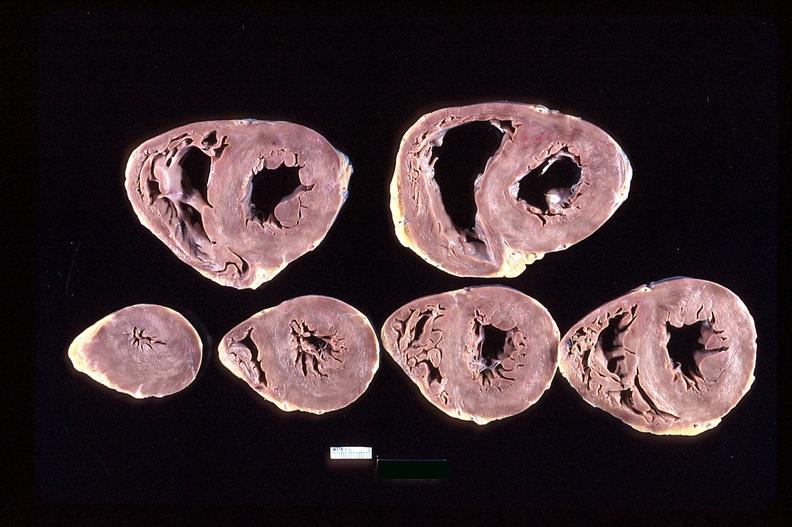what is present?
Answer the question using a single word or phrase. Cardiovascular 